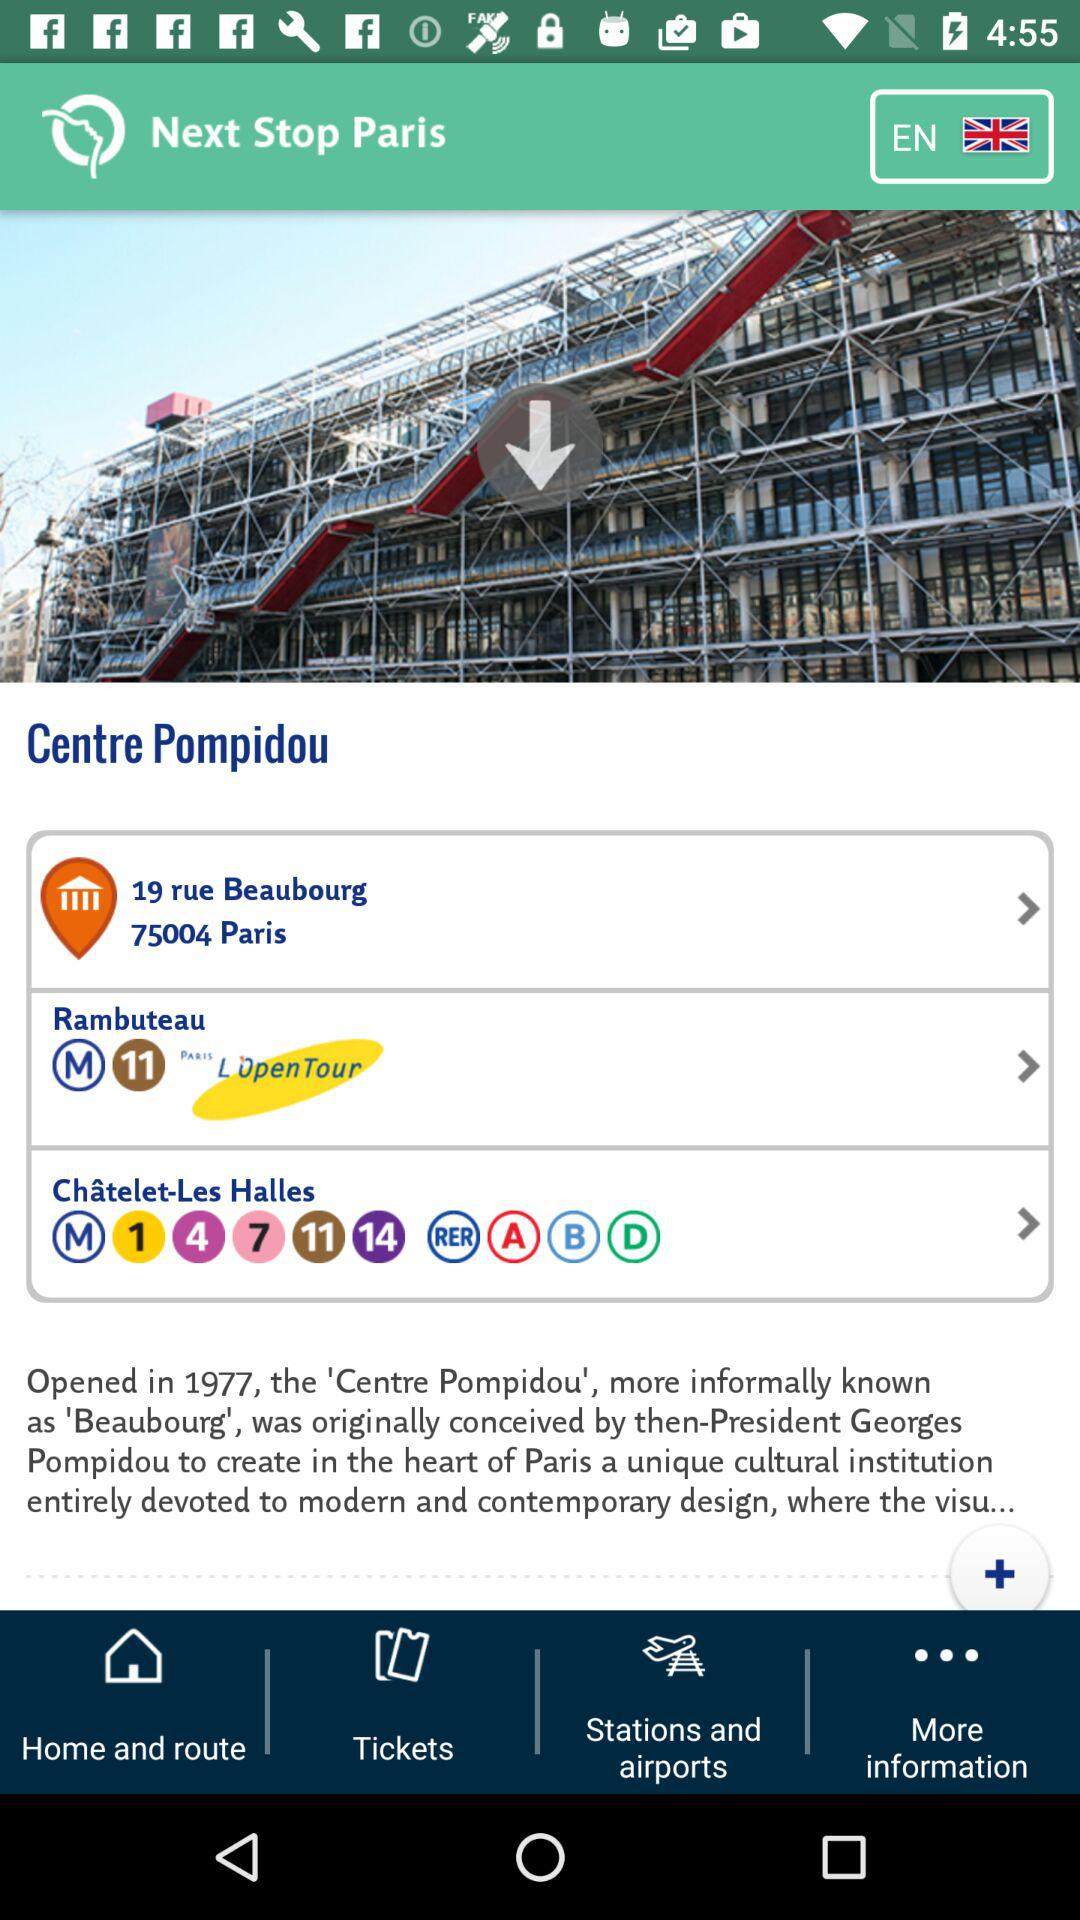What is the next stop?
When the provided information is insufficient, respond with <no answer>. <no answer> 